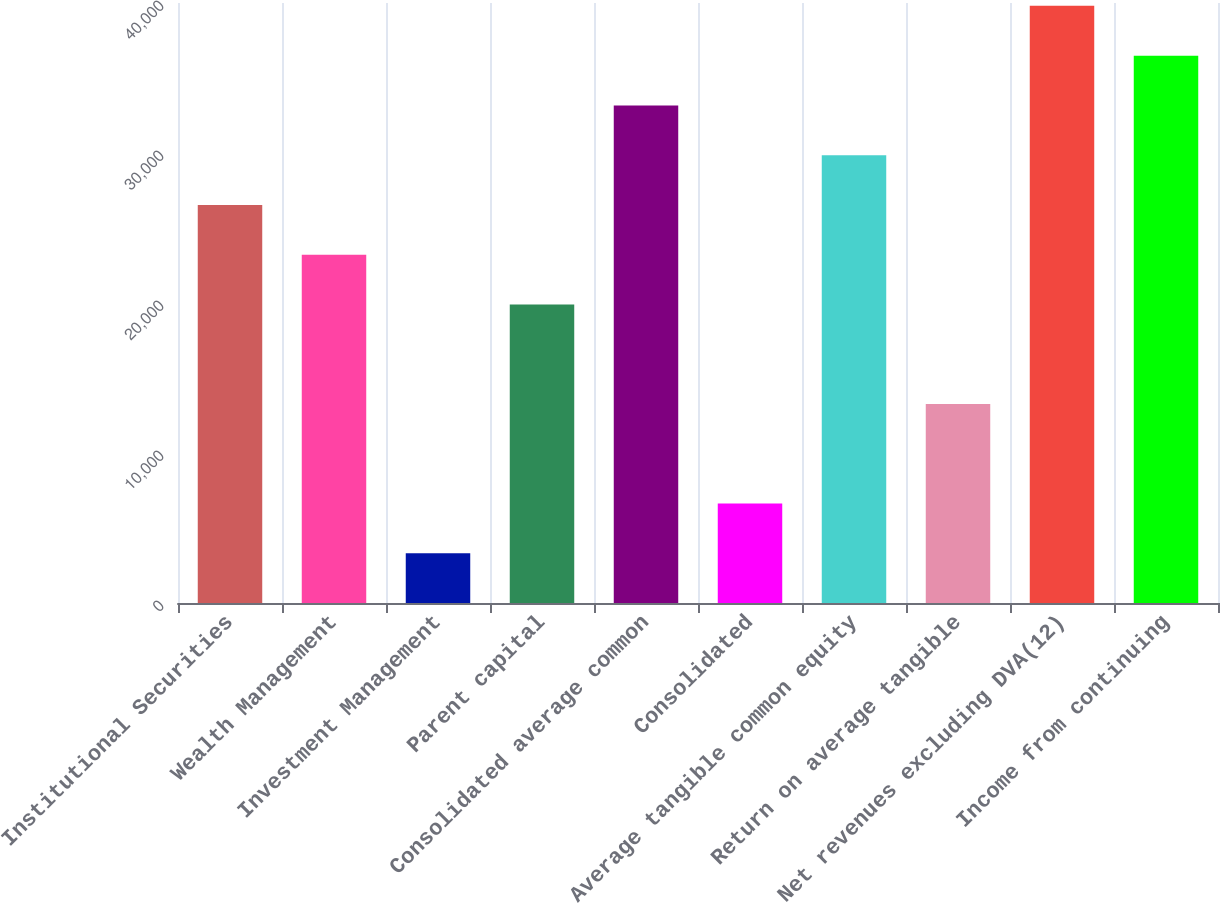<chart> <loc_0><loc_0><loc_500><loc_500><bar_chart><fcel>Institutional Securities<fcel>Wealth Management<fcel>Investment Management<fcel>Parent capital<fcel>Consolidated average common<fcel>Consolidated<fcel>Average tangible common equity<fcel>Return on average tangible<fcel>Net revenues excluding DVA(12)<fcel>Income from continuing<nl><fcel>26539.5<fcel>23222.3<fcel>3318.85<fcel>19905<fcel>33174<fcel>6636.09<fcel>29856.8<fcel>13270.6<fcel>39808.5<fcel>36491.2<nl></chart> 